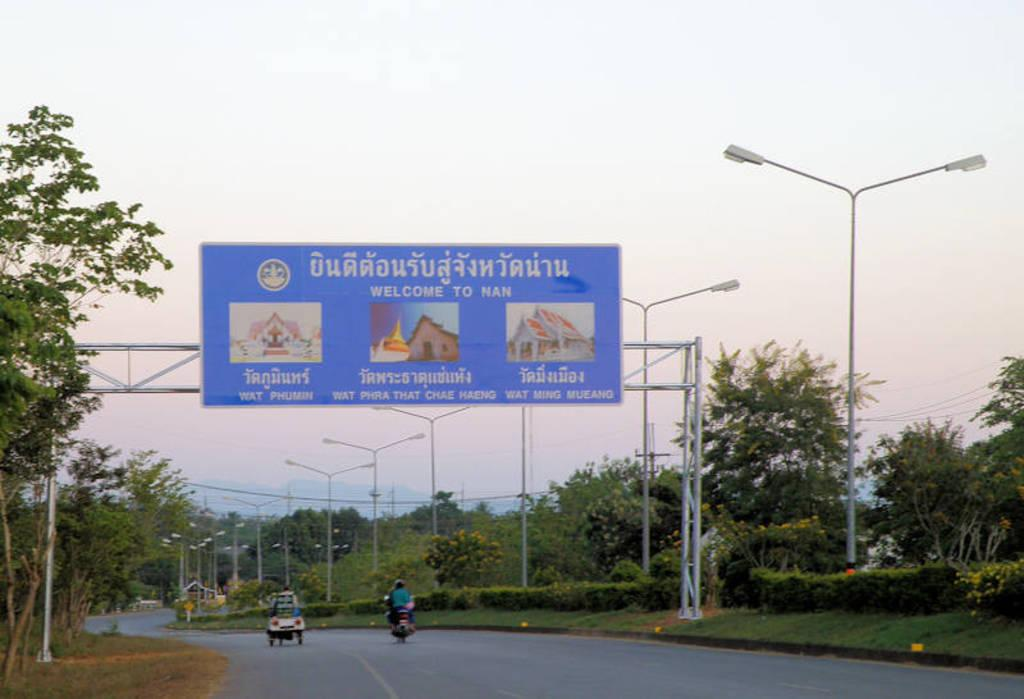<image>
Summarize the visual content of the image. A few vehicles going under a sign that says Welcome to Nan. 